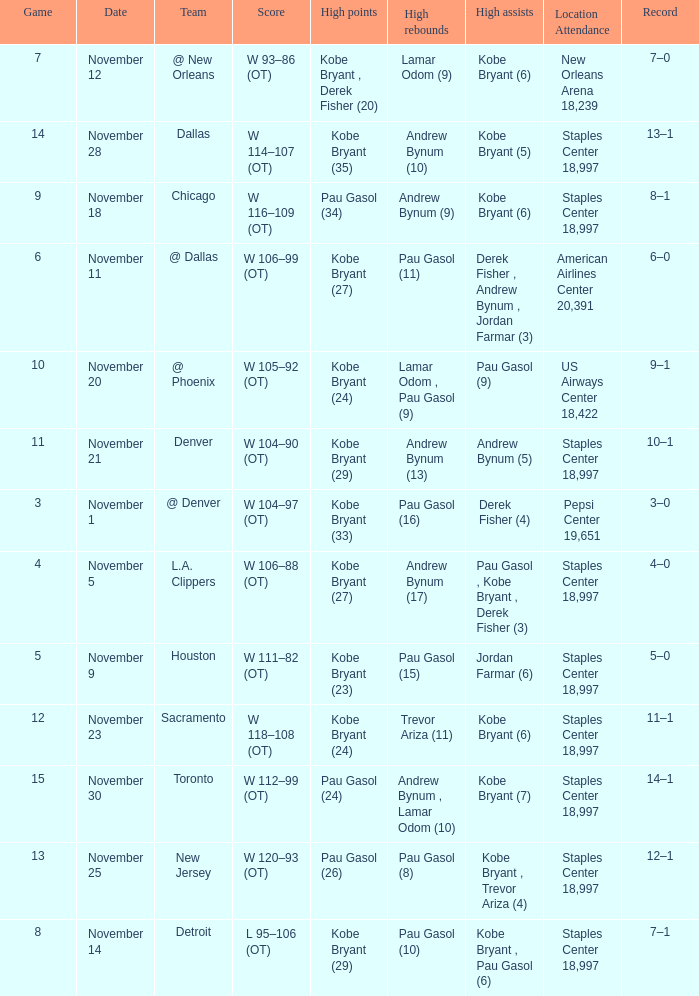What is High Assists, when High Points is "Kobe Bryant (27)", and when High Rebounds is "Pau Gasol (11)"? Derek Fisher , Andrew Bynum , Jordan Farmar (3). 